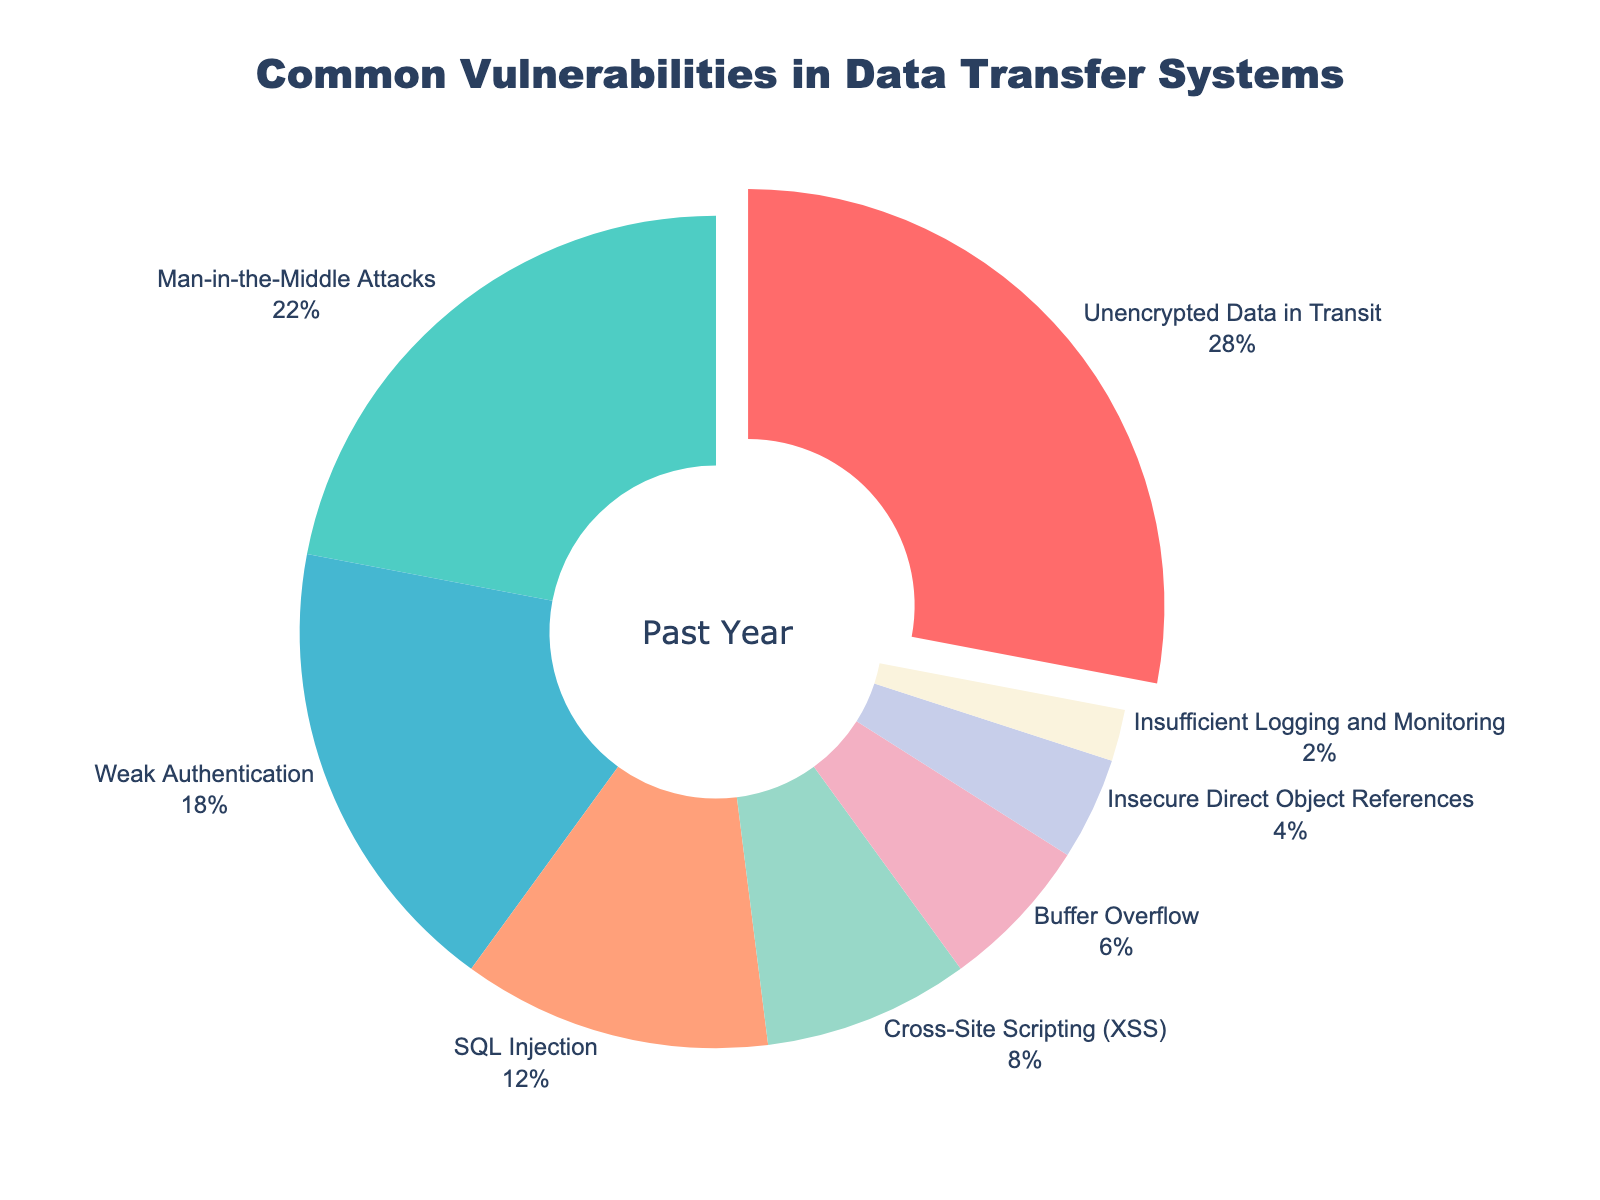What percentage of vulnerabilities is due to unencrypted data in transit? The chart shows the percentage for each vulnerability type, and unencrypted data in transit is listed as 28%.
Answer: 28% Which two vulnerabilities together constitute 40% of the total reported vulnerabilities? By adding the percentages of vulnerabilities, we find that Man-in-the-Middle Attacks (22%) and Weak Authentication (18%) together make up 40%.
Answer: Man-in-the-Middle Attacks and Weak Authentication Which vulnerability is represented with the largest section of the pie chart? The chart highlights the largest segment for unencrypted data in transit, which has the highest percentage of 28%.
Answer: Unencrypted Data in Transit What is the difference in percentage between SQL Injection and Cross-Site Scripting (XSS)? The chart lists SQL Injection at 12% and Cross-Site Scripting (XSS) at 8%, so the difference is 12% - 8% = 4%.
Answer: 4% Besides Unencrypted Data in Transit, which other vulnerability type has a significant percentage and is next in frequency? The chart shows Man-in-the-Middle Attacks as the second largest segment with a percentage of 22%.
Answer: Man-in-the-Middle Attacks By how much does the  combined percentage of the two least reported vulnerabilities exceed Insufficient Logging and Monitoring? The two least reported vulnerabilities are Insecure Direct Object References (4%) and Insufficient Logging and Monitoring (2%). The combined percentage is 6%, which exceeds Insufficient Logging and Monitoring alone by 6% - 2% = 4%.
Answer: 2% What visual element highlights the most significant vulnerability type in the pie chart? The largest section of the pie chart is slightly pulled out, indicating the highest vulnerability percentage for unencrypted data in transit.
Answer: The largest section is pulled out 